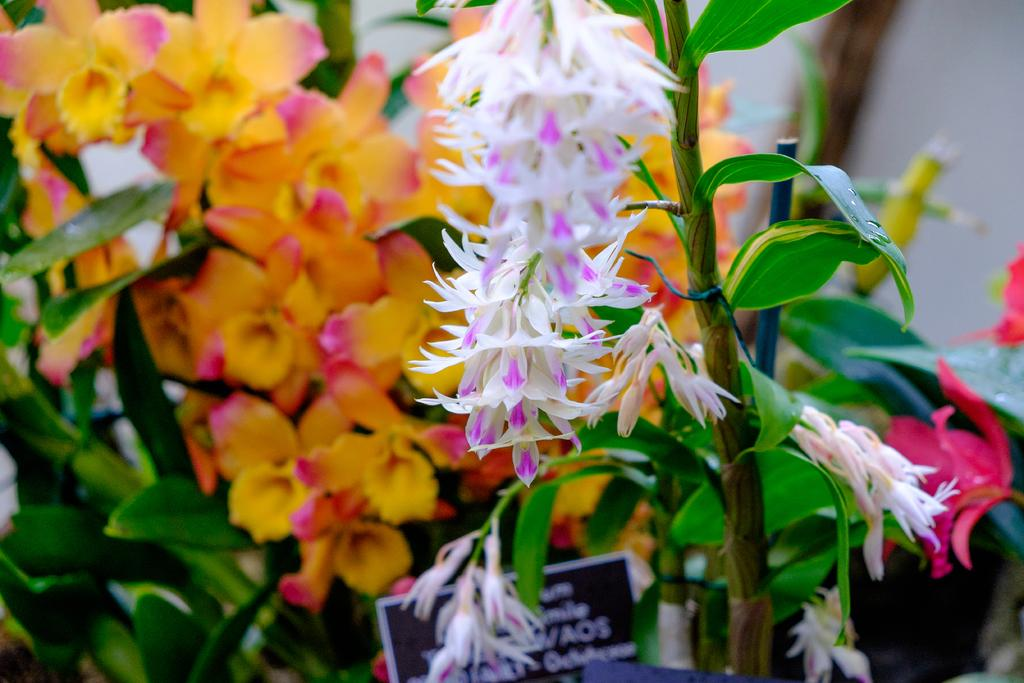What type of plants can be seen in the image? There are flowers in the image. What colors are the flowers? The flowers are in white, purple, orange, and pink colors. What else can be seen in the image besides flowers? There are leaves in the image. What color are the leaves? The leaves are green. What other object is present in the image? There is a board in the image. What colors are used for the board? The board is in black and white colors. Can you tell me how many boats are stuck in the quicksand in the image? There is no quicksand or boat present in the image; it features flowers, leaves, and a board. What level of experience is required to use the beginner's guide in the image? There is no guide or indication of experience level in the image. 